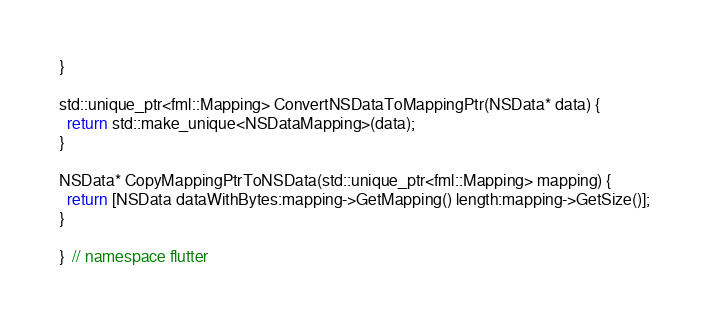Convert code to text. <code><loc_0><loc_0><loc_500><loc_500><_ObjectiveC_>}

std::unique_ptr<fml::Mapping> ConvertNSDataToMappingPtr(NSData* data) {
  return std::make_unique<NSDataMapping>(data);
}

NSData* CopyMappingPtrToNSData(std::unique_ptr<fml::Mapping> mapping) {
  return [NSData dataWithBytes:mapping->GetMapping() length:mapping->GetSize()];
}

}  // namespace flutter
</code> 